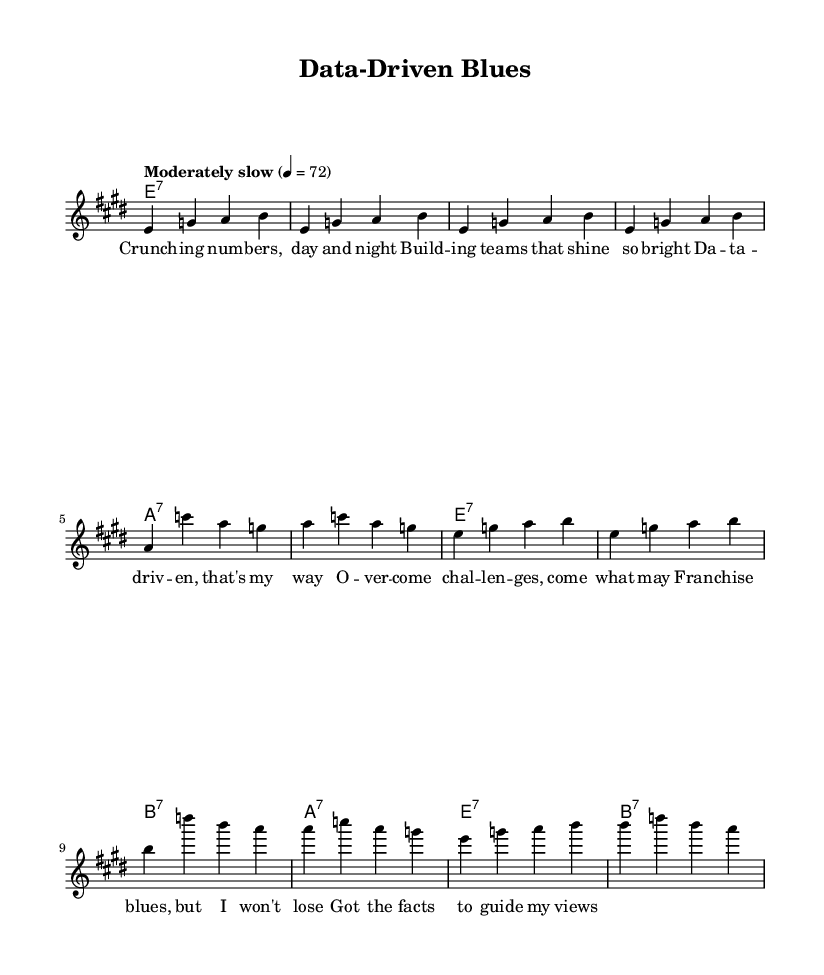What is the key signature of this music? The key signature is E major, which has four sharps: F-sharp, C-sharp, G-sharp, and D-sharp. This is evident from the key indication placed at the beginning of the staff.
Answer: E major What is the time signature of this music? The time signature is 4/4, indicating that there are four beats in each measure and that a quarter note receives one beat. This is shown at the beginning of the sheet music.
Answer: 4/4 What is the tempo marking of this music? The tempo marking is "Moderately slow" with a metronome marking of 72 beats per minute. This information is indicated under the global section of the code.
Answer: Moderately slow How many measures are in the melody? The melody contains 12 measures. This can be counted by looking at the grouping of notes and rests in the melody section, with each set of notes separated by a vertical line indicating a measure.
Answer: 12 What is the main theme of the lyrics? The main theme of the lyrics revolves around data-driven entrepreneurship and overcoming challenges. This can be inferred from the phrases that discuss "building teams," "data-driven," and "overcome challenges."
Answer: Data-driven entrepreneurship What type of chords are used predominantly in this music? The predominant type of chords used in this music is seventh chords (e7, a7, b7). This can be identified in the harmonies section where chord names denote their seventh characteristic.
Answer: Seventh chords What genre does this music belong to? This music belongs to the Blues genre, specifically Delta blues-inspired songs. This is evident from the lyrical content and stylistic elements reflected in both the melody and the chords.
Answer: Blues 